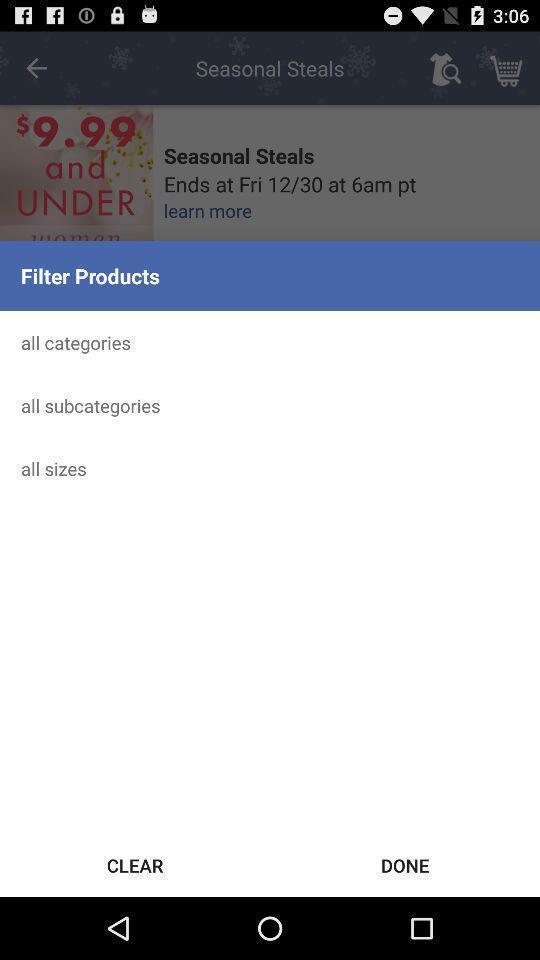Describe the visual elements of this screenshot. Screen showing filter product options. 